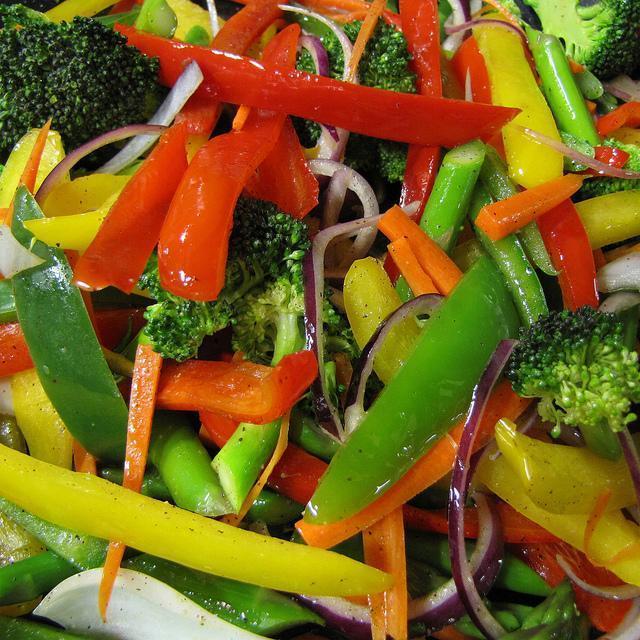How many carrots can you see?
Give a very brief answer. 8. How many broccolis are in the picture?
Give a very brief answer. 6. How many people are wearing baseball caps?
Give a very brief answer. 0. 